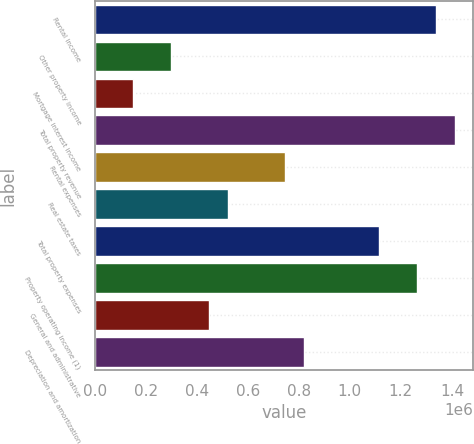<chart> <loc_0><loc_0><loc_500><loc_500><bar_chart><fcel>Rental income<fcel>Other property income<fcel>Mortgage interest income<fcel>Total property revenue<fcel>Rental expenses<fcel>Real estate taxes<fcel>Total property expenses<fcel>Property operating income (1)<fcel>General and administrative<fcel>Depreciation and amortization<nl><fcel>1.3391e+06<fcel>297694<fcel>148922<fcel>1.41349e+06<fcel>744012<fcel>520853<fcel>1.11594e+06<fcel>1.26472e+06<fcel>446467<fcel>818398<nl></chart> 